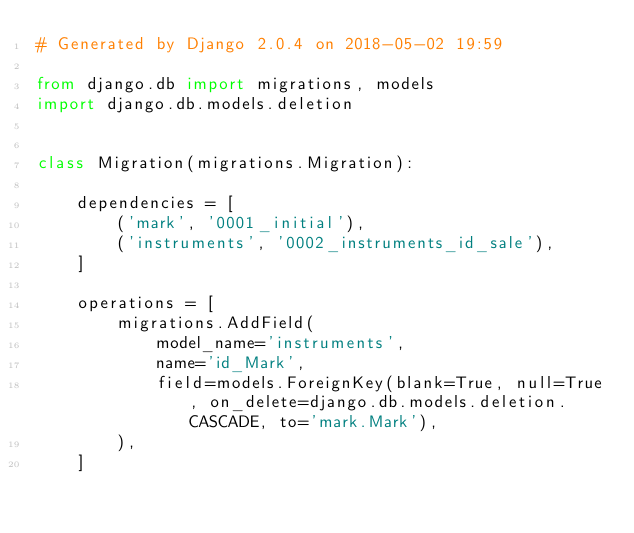<code> <loc_0><loc_0><loc_500><loc_500><_Python_># Generated by Django 2.0.4 on 2018-05-02 19:59

from django.db import migrations, models
import django.db.models.deletion


class Migration(migrations.Migration):

    dependencies = [
        ('mark', '0001_initial'),
        ('instruments', '0002_instruments_id_sale'),
    ]

    operations = [
        migrations.AddField(
            model_name='instruments',
            name='id_Mark',
            field=models.ForeignKey(blank=True, null=True, on_delete=django.db.models.deletion.CASCADE, to='mark.Mark'),
        ),
    ]
</code> 